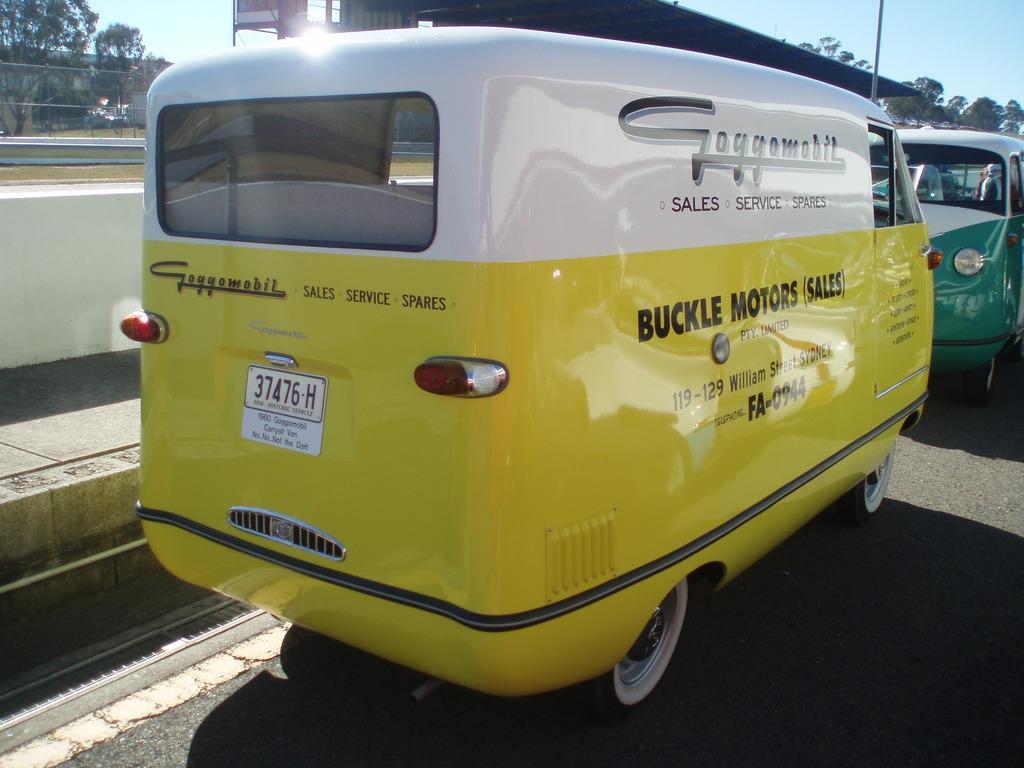Could you give a brief overview of what you see in this image? In this image there are some vehicles riding on the road, beside that there is a play ground, trees and building. 